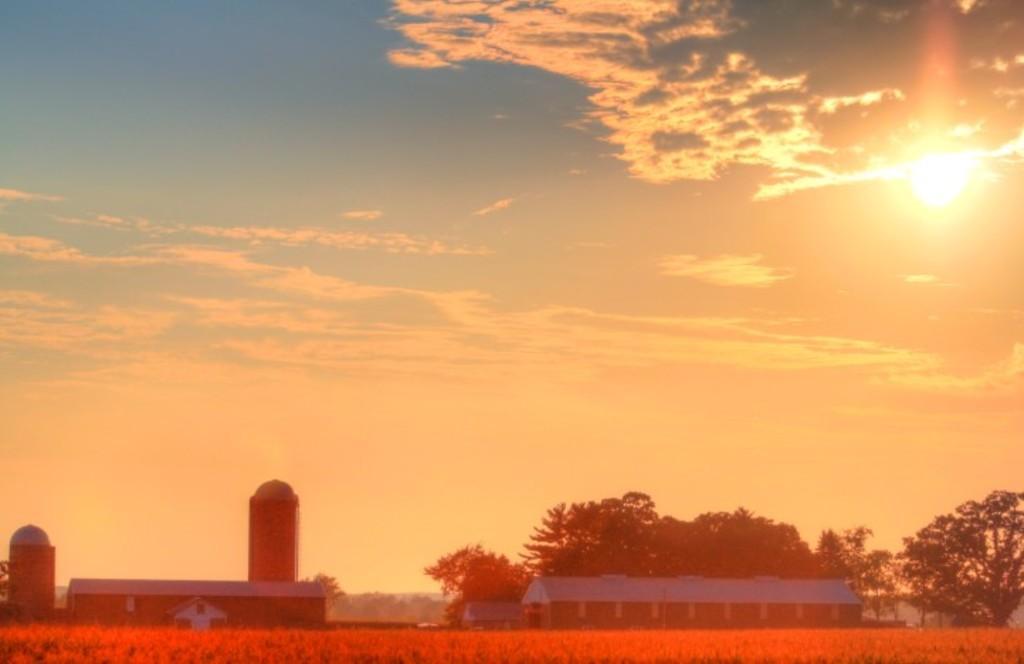Could you give a brief overview of what you see in this image? In this picture we can see grass at the bottom there is a building in the background, we can see some trees here, there is the sky at the top of the picture, we can see the Sun here. 